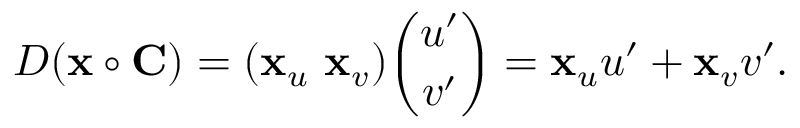Convert formula to latex. <formula><loc_0><loc_0><loc_500><loc_500>D ( x \circ C ) = ( x _ { u } \ x _ { v } ) { \binom { u ^ { \prime } } { v ^ { \prime } } } = x _ { u } u ^ { \prime } + x _ { v } v ^ { \prime } .</formula> 